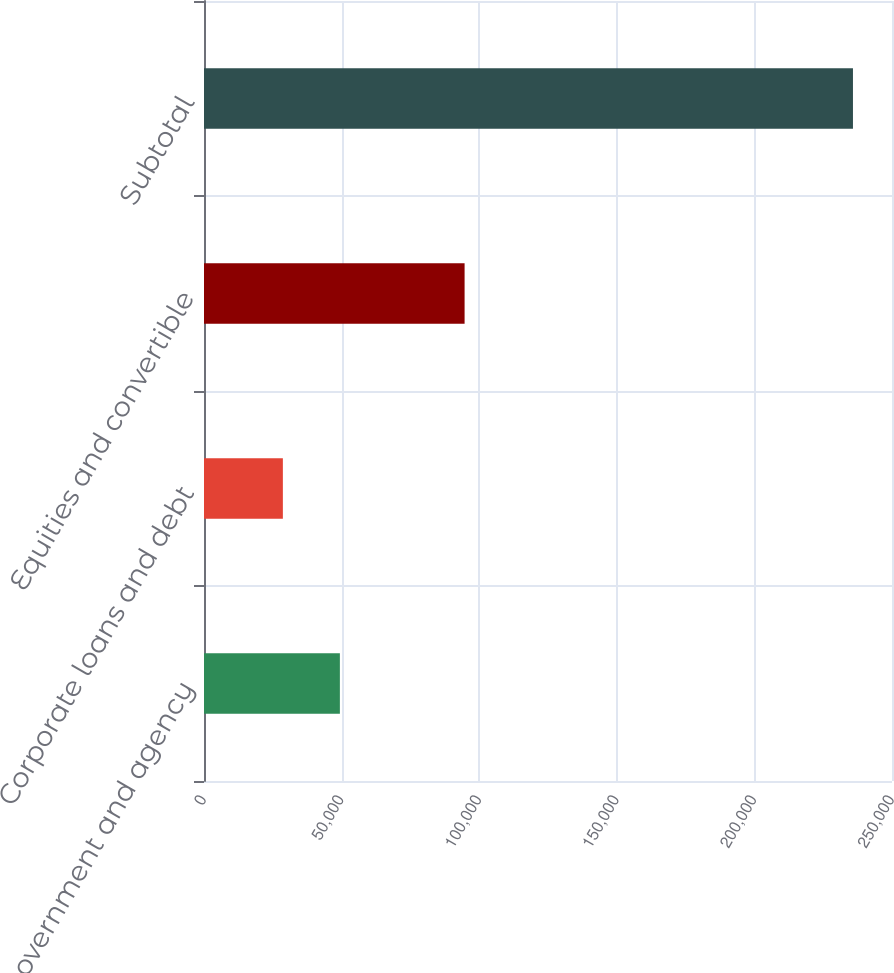<chart> <loc_0><loc_0><loc_500><loc_500><bar_chart><fcel>Non-US government and agency<fcel>Corporate loans and debt<fcel>Equities and convertible<fcel>Subtotal<nl><fcel>49374.6<fcel>28659<fcel>94692<fcel>235815<nl></chart> 